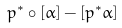Convert formula to latex. <formula><loc_0><loc_0><loc_500><loc_500>p ^ { * } \circ [ \alpha ] - [ p ^ { * } \alpha ]</formula> 